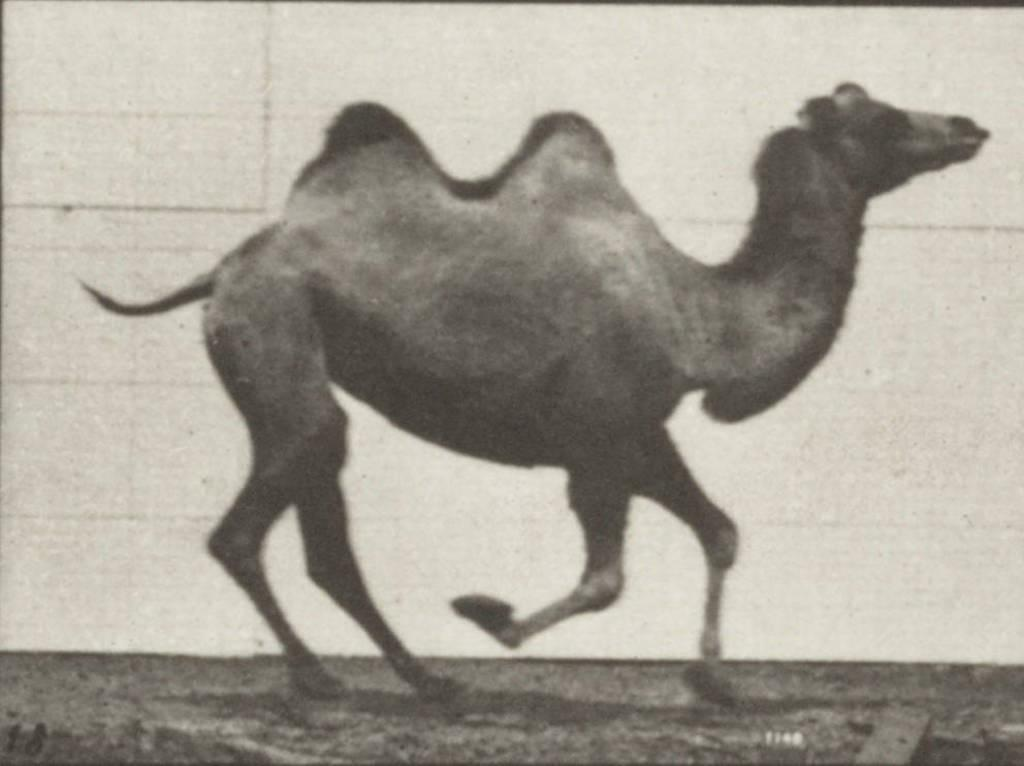What animal is the main subject of the image? There is a camel in the image. What is the camel doing in the image? The camel is running in the image. Where is the camel located in the image? The camel is on a road in the image. What year is depicted in the image? The image does not depict a specific year; it only shows a camel running on a road. Can you tell me how many times the camel falls in the image? The camel does not fall in the image; it is running on the road. 